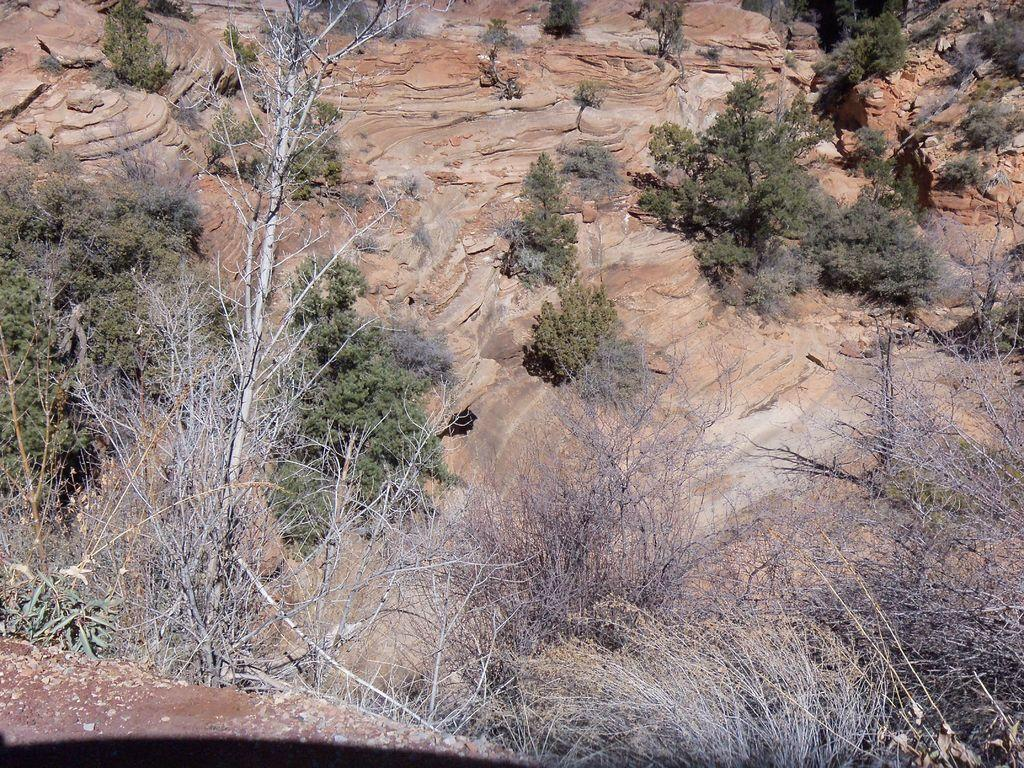What type of natural elements can be seen in the image? There are trees and rocks in the image. Can you describe the trees in the image? The provided facts do not give specific details about the trees, but we can confirm that trees are present. What other objects or features can be seen in the image? The provided facts only mention trees and rocks, so there is no additional information about other objects or features. What type of haircut does the creature in the image have? There is no creature present in the image, so it is not possible to answer that question. 